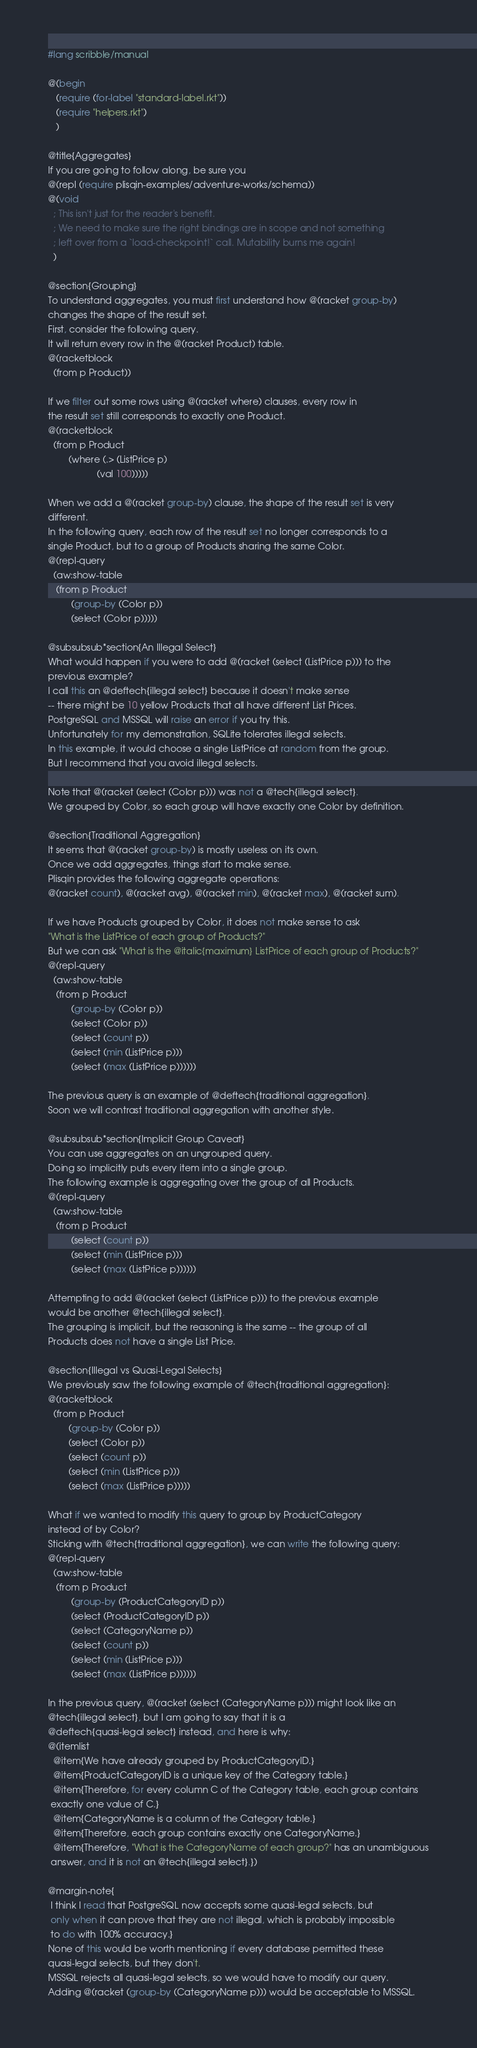<code> <loc_0><loc_0><loc_500><loc_500><_Racket_>#lang scribble/manual

@(begin
   (require (for-label "standard-label.rkt"))
   (require "helpers.rkt")
   )

@title{Aggregates}
If you are going to follow along, be sure you
@(repl (require plisqin-examples/adventure-works/schema))
@(void
  ; This isn't just for the reader's benefit.
  ; We need to make sure the right bindings are in scope and not something
  ; left over from a `load-checkpoint!` call. Mutability burns me again!
  )

@section{Grouping}
To understand aggregates, you must first understand how @(racket group-by)
changes the shape of the result set.
First, consider the following query.
It will return every row in the @(racket Product) table.
@(racketblock
  (from p Product))

If we filter out some rows using @(racket where) clauses, every row in
the result set still corresponds to exactly one Product.
@(racketblock
  (from p Product
        (where (.> (ListPrice p)
                   (val 100)))))

When we add a @(racket group-by) clause, the shape of the result set is very
different.
In the following query, each row of the result set no longer corresponds to a
single Product, but to a group of Products sharing the same Color.
@(repl-query
  (aw:show-table
   (from p Product
         (group-by (Color p))
         (select (Color p)))))

@subsubsub*section{An Illegal Select}
What would happen if you were to add @(racket (select (ListPrice p))) to the
previous example?
I call this an @deftech{illegal select} because it doesn't make sense
-- there might be 10 yellow Products that all have different List Prices.
PostgreSQL and MSSQL will raise an error if you try this.
Unfortunately for my demonstration, SQLite tolerates illegal selects.
In this example, it would choose a single ListPrice at random from the group.
But I recommend that you avoid illegal selects.

Note that @(racket (select (Color p))) was not a @tech{illegal select}.
We grouped by Color, so each group will have exactly one Color by definition.

@section{Traditional Aggregation}
It seems that @(racket group-by) is mostly useless on its own.
Once we add aggregates, things start to make sense.
Plisqin provides the following aggregate operations:
@(racket count), @(racket avg), @(racket min), @(racket max), @(racket sum).

If we have Products grouped by Color, it does not make sense to ask
"What is the ListPrice of each group of Products?"
But we can ask "What is the @italic{maximum} ListPrice of each group of Products?"
@(repl-query
  (aw:show-table
   (from p Product
         (group-by (Color p))
         (select (Color p))
         (select (count p))
         (select (min (ListPrice p)))
         (select (max (ListPrice p))))))

The previous query is an example of @deftech{traditional aggregation}.
Soon we will contrast traditional aggregation with another style.

@subsubsub*section{Implicit Group Caveat}
You can use aggregates on an ungrouped query.
Doing so implicitly puts every item into a single group.
The following example is aggregating over the group of all Products.
@(repl-query
  (aw:show-table
   (from p Product
         (select (count p))
         (select (min (ListPrice p)))
         (select (max (ListPrice p))))))

Attempting to add @(racket (select (ListPrice p))) to the previous example
would be another @tech{illegal select}.
The grouping is implicit, but the reasoning is the same -- the group of all
Products does not have a single List Price.

@section{Illegal vs Quasi-Legal Selects}
We previously saw the following example of @tech{traditional aggregation}:
@(racketblock
  (from p Product
        (group-by (Color p))
        (select (Color p))
        (select (count p))
        (select (min (ListPrice p)))
        (select (max (ListPrice p)))))

What if we wanted to modify this query to group by ProductCategory
instead of by Color?
Sticking with @tech{traditional aggregation}, we can write the following query:
@(repl-query
  (aw:show-table
   (from p Product
         (group-by (ProductCategoryID p))
         (select (ProductCategoryID p))
         (select (CategoryName p))
         (select (count p))
         (select (min (ListPrice p)))
         (select (max (ListPrice p))))))

In the previous query, @(racket (select (CategoryName p))) might look like an
@tech{illegal select}, but I am going to say that it is a
@deftech{quasi-legal select} instead, and here is why:
@(itemlist
  @item{We have already grouped by ProductCategoryID.}
  @item{ProductCategoryID is a unique key of the Category table.}
  @item{Therefore, for every column C of the Category table, each group contains
 exactly one value of C.}
  @item{CategoryName is a column of the Category table.}
  @item{Therefore, each group contains exactly one CategoryName.}
  @item{Therefore, "What is the CategoryName of each group?" has an unambiguous
 answer, and it is not an @tech{illegal select}.})

@margin-note{
 I think I read that PostgreSQL now accepts some quasi-legal selects, but
 only when it can prove that they are not illegal, which is probably impossible
 to do with 100% accuracy.}
None of this would be worth mentioning if every database permitted these
quasi-legal selects, but they don't.
MSSQL rejects all quasi-legal selects, so we would have to modify our query.
Adding @(racket (group-by (CategoryName p))) would be acceptable to MSSQL.</code> 